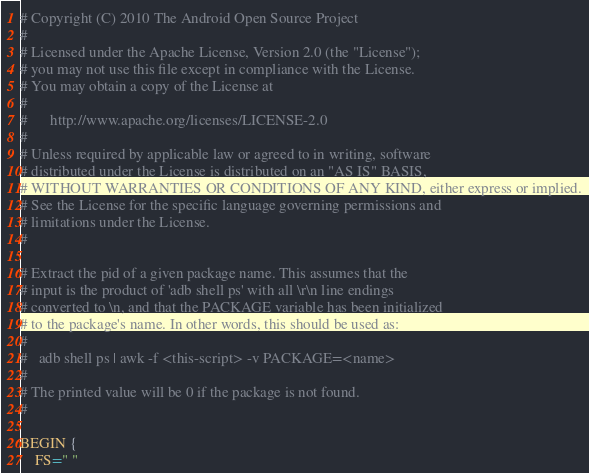<code> <loc_0><loc_0><loc_500><loc_500><_Awk_># Copyright (C) 2010 The Android Open Source Project
#
# Licensed under the Apache License, Version 2.0 (the "License");
# you may not use this file except in compliance with the License.
# You may obtain a copy of the License at
#
#      http://www.apache.org/licenses/LICENSE-2.0
#
# Unless required by applicable law or agreed to in writing, software
# distributed under the License is distributed on an "AS IS" BASIS,
# WITHOUT WARRANTIES OR CONDITIONS OF ANY KIND, either express or implied.
# See the License for the specific language governing permissions and
# limitations under the License.
#

# Extract the pid of a given package name. This assumes that the
# input is the product of 'adb shell ps' with all \r\n line endings
# converted to \n, and that the PACKAGE variable has been initialized
# to the package's name. In other words, this should be used as:
#
#   adb shell ps | awk -f <this-script> -v PACKAGE=<name>
#
# The printed value will be 0 if the package is not found.
#

BEGIN {
    FS=" "
</code> 